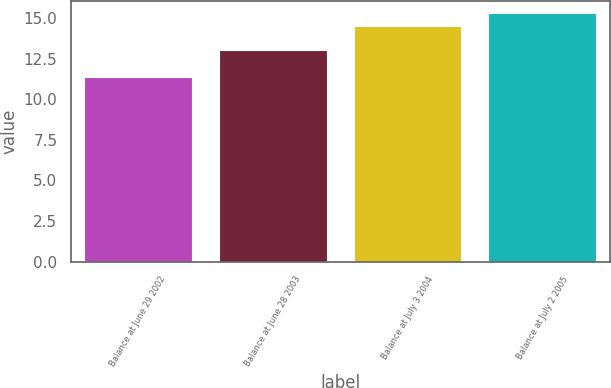Convert chart. <chart><loc_0><loc_0><loc_500><loc_500><bar_chart><fcel>Balance at June 29 2002<fcel>Balance at June 28 2003<fcel>Balance at July 3 2004<fcel>Balance at July 2 2005<nl><fcel>11.38<fcel>13.01<fcel>14.5<fcel>15.29<nl></chart> 